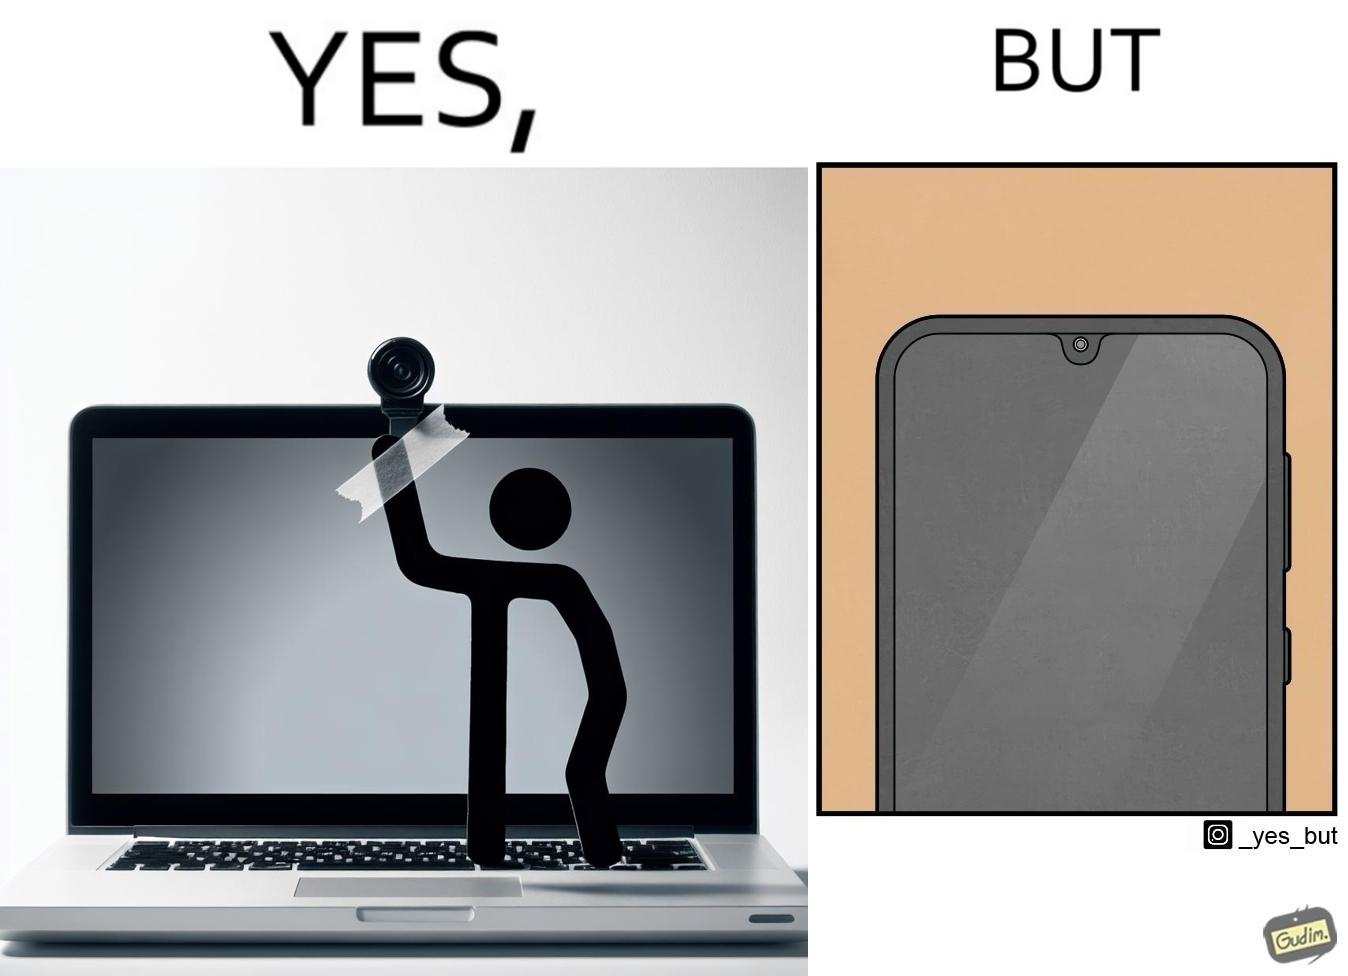Describe what you see in this image. The image is ironic, because the person is seen as applying tape over laptop's camera over some privacy concerns but on the other hand he/she carries the phone without covering its camera 